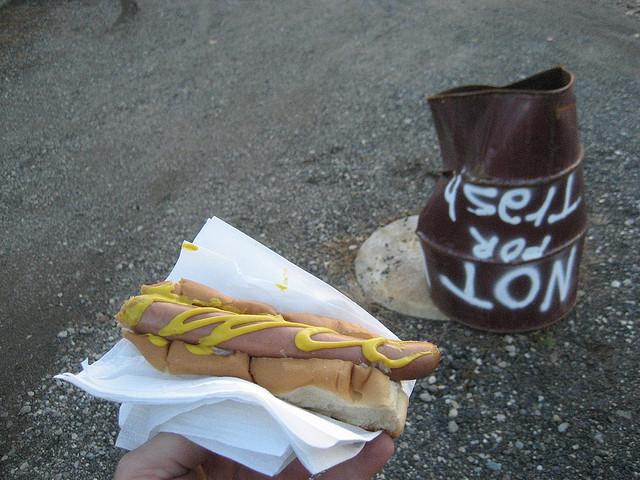What is on the hot dog?
Give a very brief answer. Mustard. Is this healthy?
Answer briefly. No. What kind of food is on the paper?
Answer briefly. Hot dog. 